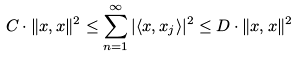<formula> <loc_0><loc_0><loc_500><loc_500>C \cdot \| x , x \| ^ { 2 } \leq \sum _ { n = 1 } ^ { \infty } | \langle x , x _ { j } \rangle | ^ { 2 } \leq D \cdot \| x , x \| ^ { 2 }</formula> 